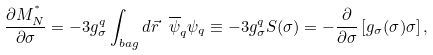Convert formula to latex. <formula><loc_0><loc_0><loc_500><loc_500>\frac { \partial M _ { N } ^ { ^ { * } } } { \partial \sigma } = - 3 g _ { \sigma } ^ { q } \int _ { b a g } d { \vec { r } } \ { \overline { \psi } } _ { q } \psi _ { q } \equiv - 3 g _ { \sigma } ^ { q } S ( \sigma ) = - \frac { \partial } { \partial \sigma } \left [ g _ { \sigma } ( \sigma ) \sigma \right ] ,</formula> 